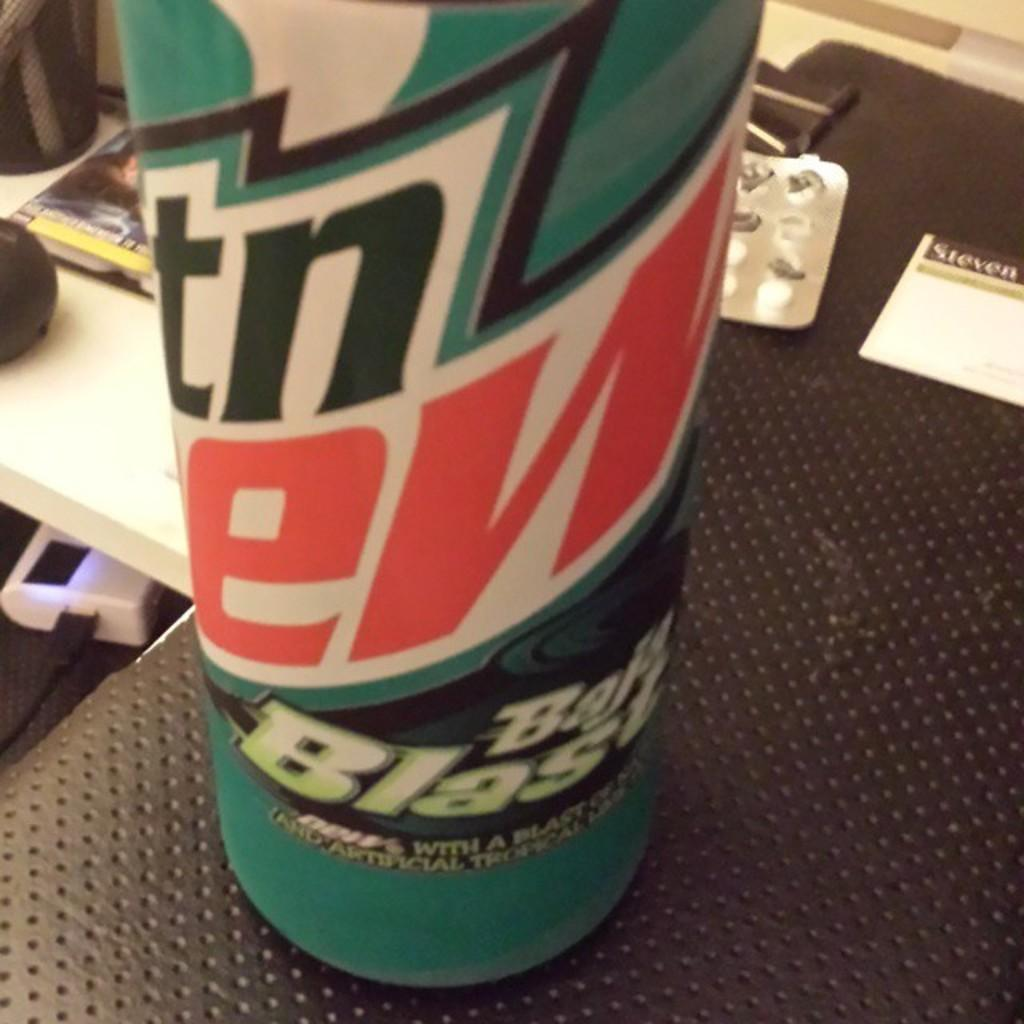Provide a one-sentence caption for the provided image. A Bala Blasa soda can sitting on a black shelf next to paper. 